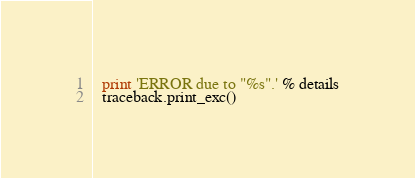<code> <loc_0><loc_0><loc_500><loc_500><_Python_>  print 'ERROR due to "%s".' % details
  traceback.print_exc()</code> 